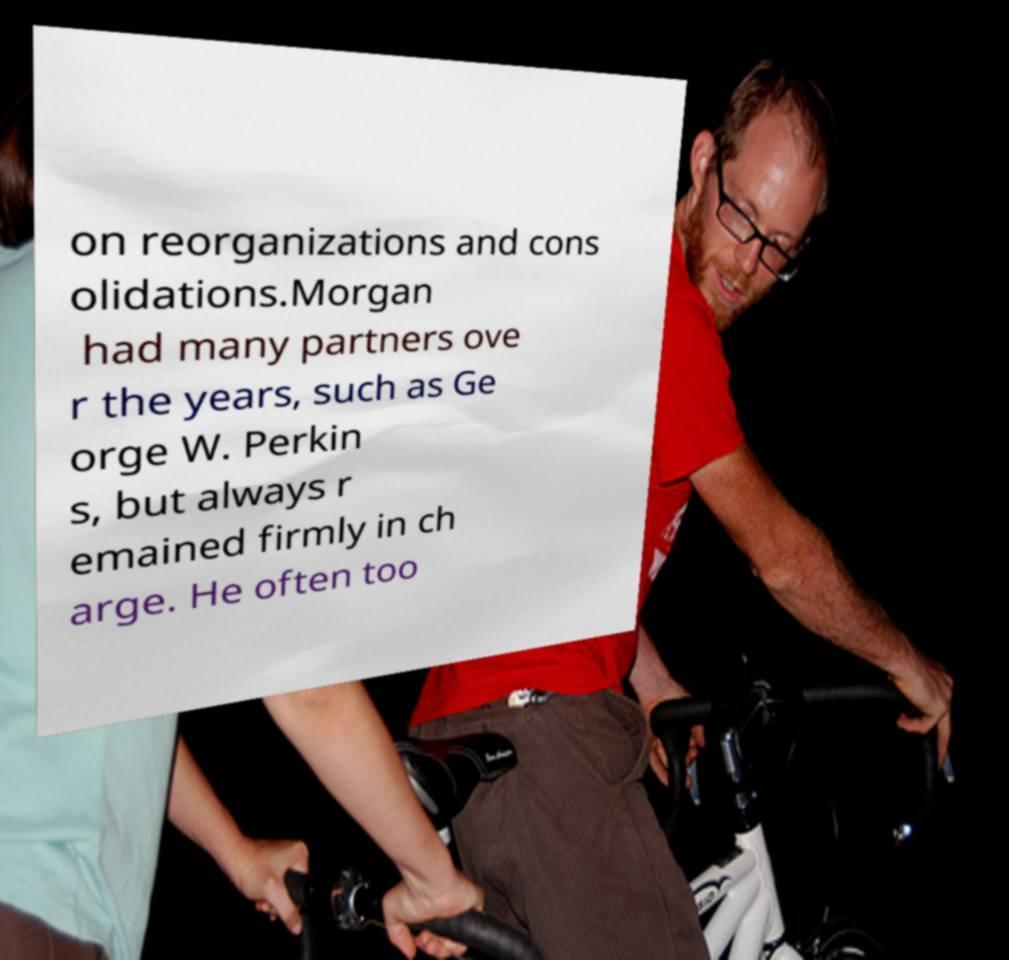Please identify and transcribe the text found in this image. on reorganizations and cons olidations.Morgan had many partners ove r the years, such as Ge orge W. Perkin s, but always r emained firmly in ch arge. He often too 